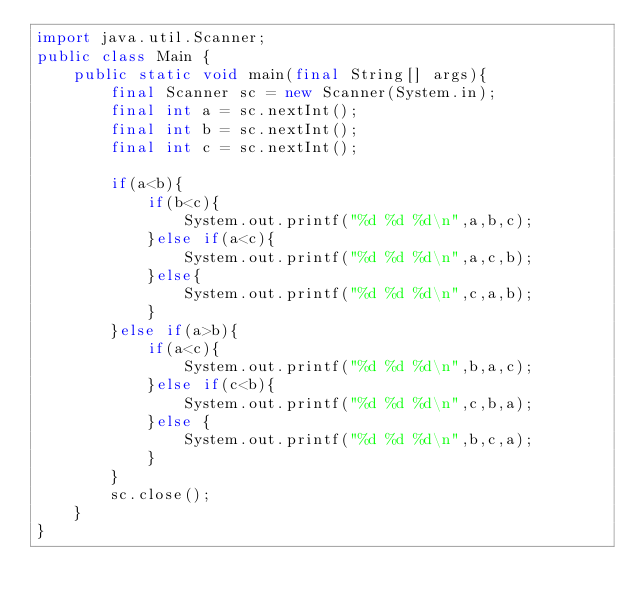Convert code to text. <code><loc_0><loc_0><loc_500><loc_500><_Java_>import java.util.Scanner;
public class Main {
    public static void main(final String[] args){
        final Scanner sc = new Scanner(System.in);
        final int a = sc.nextInt();
        final int b = sc.nextInt();
        final int c = sc.nextInt();

        if(a<b){
            if(b<c){
                System.out.printf("%d %d %d\n",a,b,c);
            }else if(a<c){
                System.out.printf("%d %d %d\n",a,c,b);
            }else{
                System.out.printf("%d %d %d\n",c,a,b);
            }
        }else if(a>b){
            if(a<c){
                System.out.printf("%d %d %d\n",b,a,c);
            }else if(c<b){
                System.out.printf("%d %d %d\n",c,b,a);
            }else {
                System.out.printf("%d %d %d\n",b,c,a);
            }
        }
        sc.close();
    }
}
</code> 